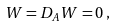<formula> <loc_0><loc_0><loc_500><loc_500>W = D _ { A } W = 0 \, ,</formula> 